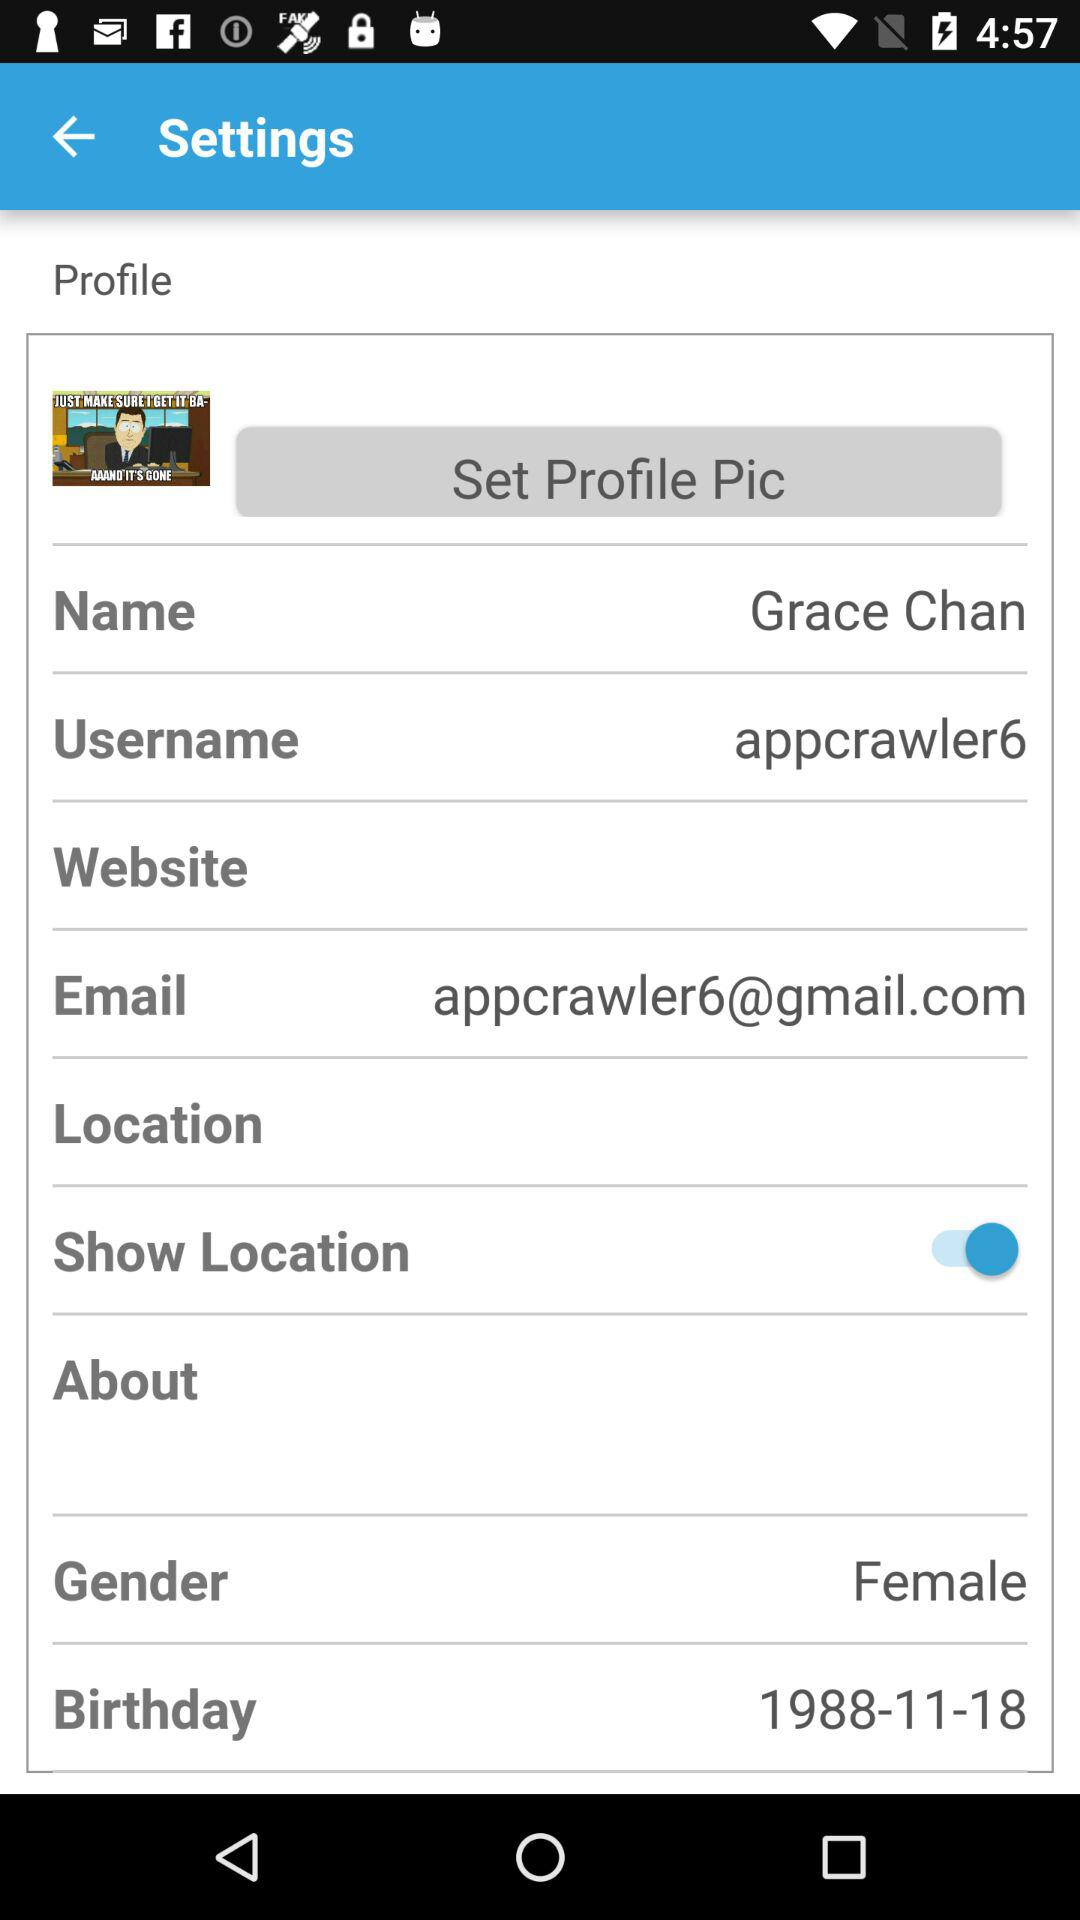What is the gender? The gender is female. 